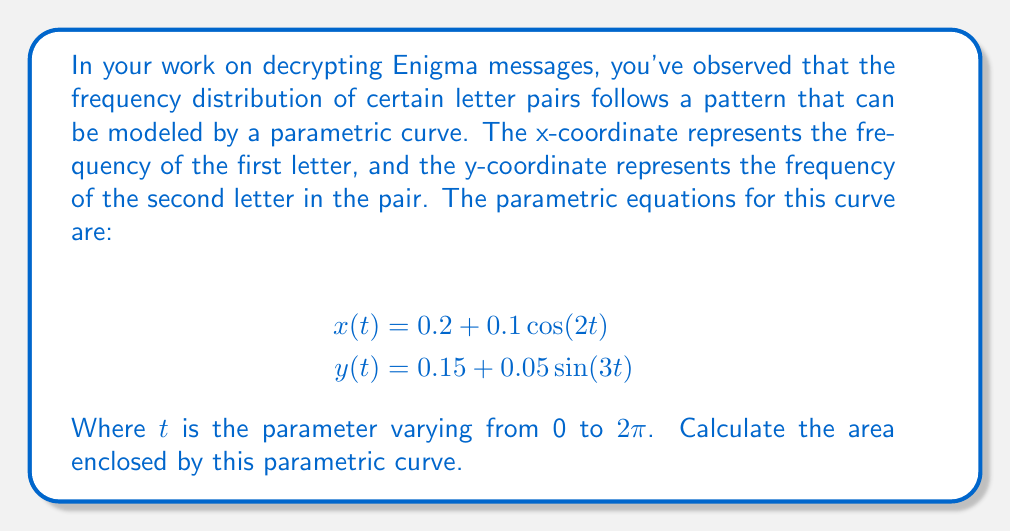Show me your answer to this math problem. To find the area enclosed by a parametric curve, we can use Green's theorem, which states that the area is given by:

$$A = \frac{1}{2} \int_0^{2\pi} [x(t)y'(t) - y(t)x'(t)] dt$$

Let's follow these steps:

1) First, we need to find $x'(t)$ and $y'(t)$:
   $$x'(t) = -0.2 \sin(2t)$$
   $$y'(t) = 0.15 \cos(3t)$$

2) Now, let's substitute these into the integral:
   $$A = \frac{1}{2} \int_0^{2\pi} [(0.2 + 0.1 \cos(2t))(0.15 \cos(3t)) - (0.15 + 0.05 \sin(3t))(-0.2 \sin(2t))] dt$$

3) Expand the expression inside the integral:
   $$A = \frac{1}{2} \int_0^{2\pi} [0.03 \cos(3t) + 0.015 \cos(2t)\cos(3t) + 0.03 \sin(2t) + 0.01 \sin(2t)\sin(3t)] dt$$

4) Now, we need to integrate each term:
   - $\int_0^{2\pi} \cos(3t) dt = 0$
   - $\int_0^{2\pi} \cos(2t)\cos(3t) dt = 0$
   - $\int_0^{2\pi} \sin(2t) dt = 0$
   - $\int_0^{2\pi} \sin(2t)\sin(3t) dt = \pi$

5) After integration:
   $$A = \frac{1}{2} [0 + 0 + 0 + 0.01\pi]$$

6) Simplify:
   $$A = 0.005\pi$$

Therefore, the area enclosed by the parametric curve is $0.005\pi$ square units.
Answer: $0.005\pi$ square units 